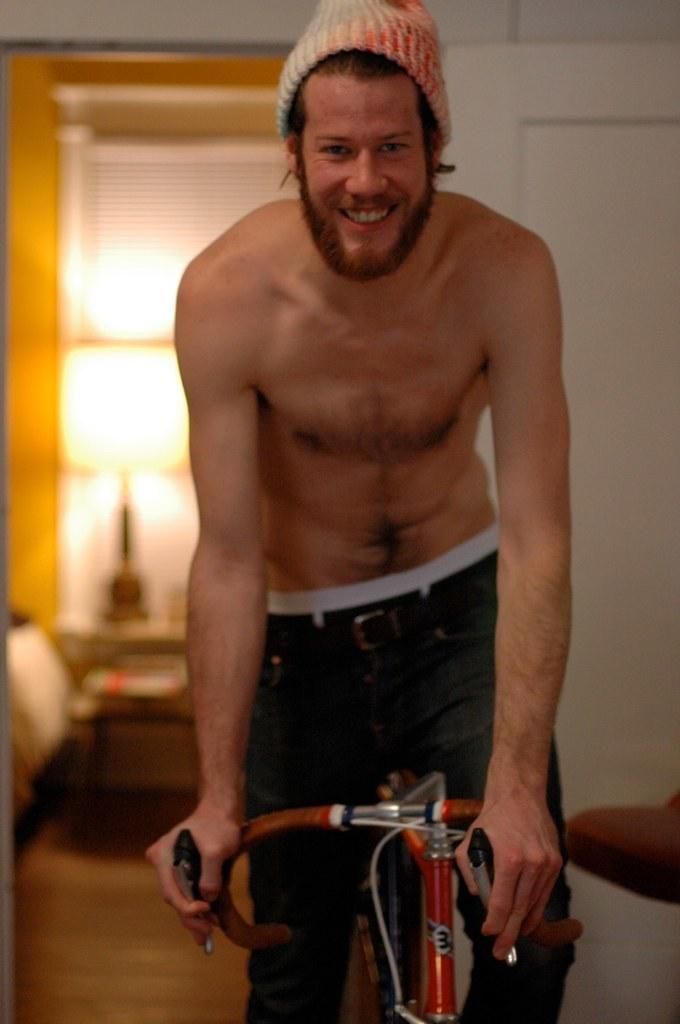Who or what is the main subject in the image? There is a person in the image. What is the person doing in the image? The person is on a bicycle. Can you describe the person's attire in the image? The person is wearing a cap. What is the person's facial expression in the image? The person is smiling. How many bulbs are hanging from the person's bicycle in the image? There are no bulbs present in the image. What type of pear is the person holding in the image? There is no pear present in the image. 